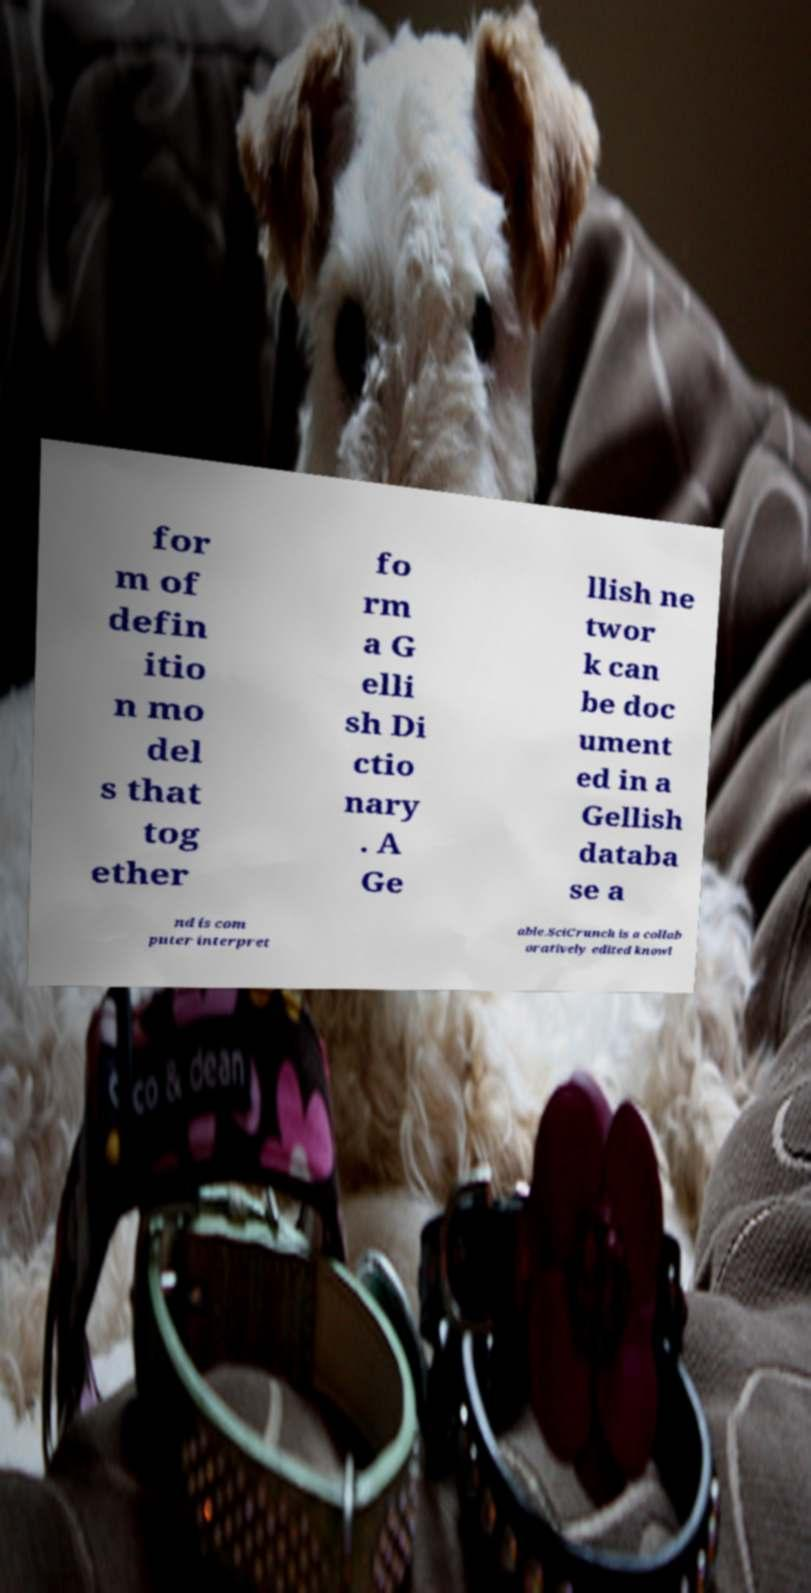There's text embedded in this image that I need extracted. Can you transcribe it verbatim? for m of defin itio n mo del s that tog ether fo rm a G elli sh Di ctio nary . A Ge llish ne twor k can be doc ument ed in a Gellish databa se a nd is com puter interpret able.SciCrunch is a collab oratively edited knowl 